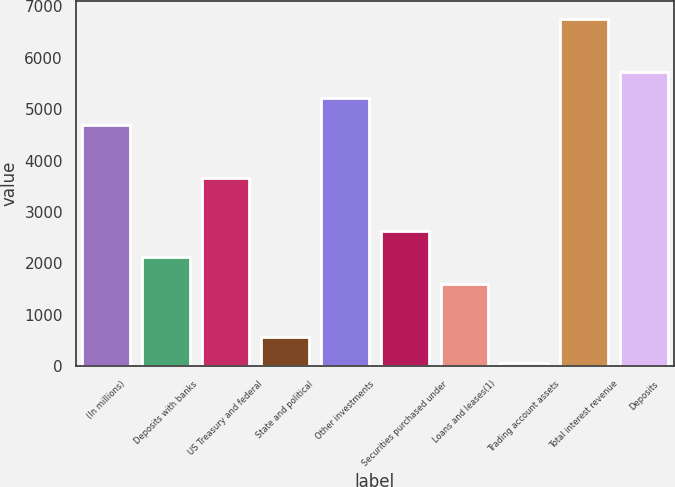Convert chart. <chart><loc_0><loc_0><loc_500><loc_500><bar_chart><fcel>(In millions)<fcel>Deposits with banks<fcel>US Treasury and federal<fcel>State and political<fcel>Other investments<fcel>Securities purchased under<fcel>Loans and leases(1)<fcel>Trading account assets<fcel>Total interest revenue<fcel>Deposits<nl><fcel>4696.3<fcel>2117.8<fcel>3664.9<fcel>570.7<fcel>5212<fcel>2633.5<fcel>1602.1<fcel>55<fcel>6759.1<fcel>5727.7<nl></chart> 